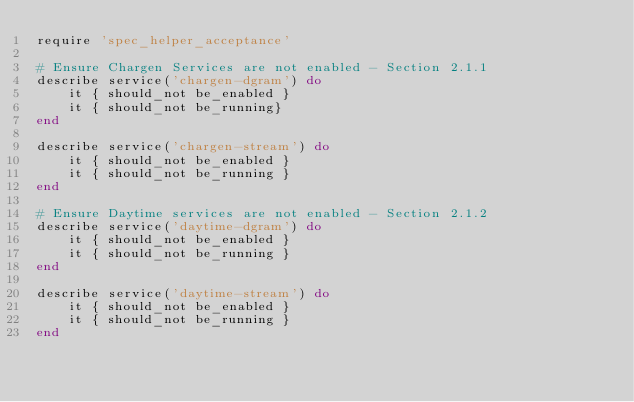<code> <loc_0><loc_0><loc_500><loc_500><_Ruby_>require 'spec_helper_acceptance'

# Ensure Chargen Services are not enabled - Section 2.1.1
describe service('chargen-dgram') do
    it { should_not be_enabled }
    it { should_not be_running}
end

describe service('chargen-stream') do
    it { should_not be_enabled }
    it { should_not be_running }
end

# Ensure Daytime services are not enabled - Section 2.1.2
describe service('daytime-dgram') do
    it { should_not be_enabled }
    it { should_not be_running }
end

describe service('daytime-stream') do
    it { should_not be_enabled }
    it { should_not be_running }
end</code> 